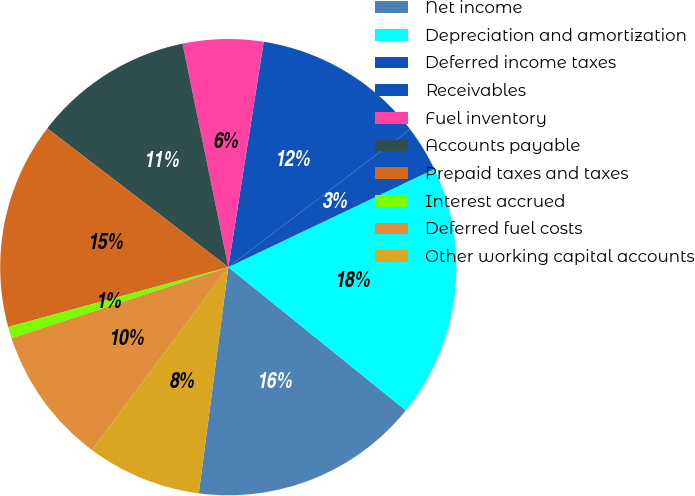<chart> <loc_0><loc_0><loc_500><loc_500><pie_chart><fcel>Net income<fcel>Depreciation and amortization<fcel>Deferred income taxes<fcel>Receivables<fcel>Fuel inventory<fcel>Accounts payable<fcel>Prepaid taxes and taxes<fcel>Interest accrued<fcel>Deferred fuel costs<fcel>Other working capital accounts<nl><fcel>16.26%<fcel>17.88%<fcel>3.26%<fcel>12.19%<fcel>5.69%<fcel>11.38%<fcel>14.63%<fcel>0.82%<fcel>9.76%<fcel>8.13%<nl></chart> 